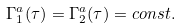Convert formula to latex. <formula><loc_0><loc_0><loc_500><loc_500>\Gamma _ { 1 } ^ { a } ( \tau ) = \Gamma _ { 2 } ^ { a } ( \tau ) = c o n s t .</formula> 